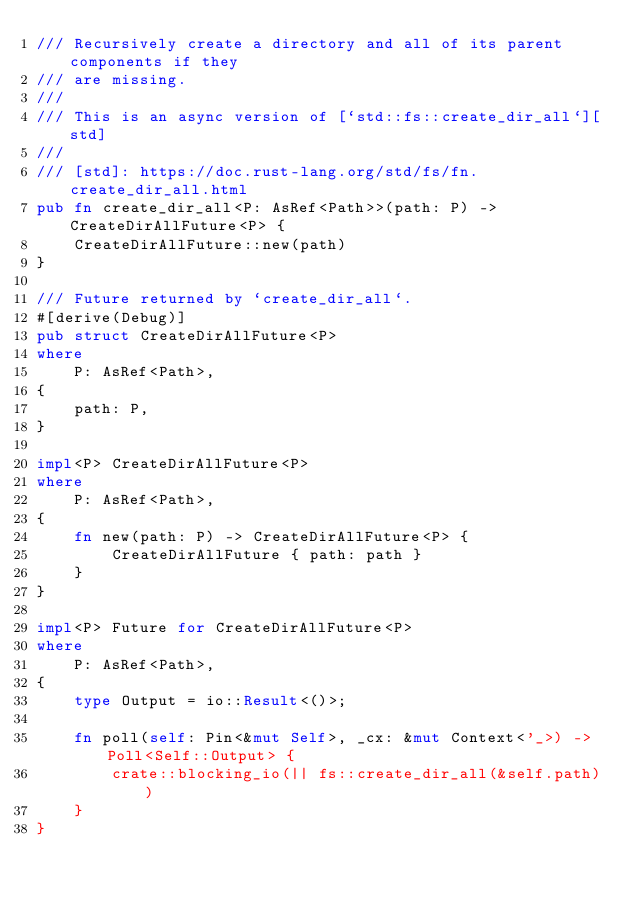<code> <loc_0><loc_0><loc_500><loc_500><_Rust_>/// Recursively create a directory and all of its parent components if they
/// are missing.
///
/// This is an async version of [`std::fs::create_dir_all`][std]
///
/// [std]: https://doc.rust-lang.org/std/fs/fn.create_dir_all.html
pub fn create_dir_all<P: AsRef<Path>>(path: P) -> CreateDirAllFuture<P> {
    CreateDirAllFuture::new(path)
}

/// Future returned by `create_dir_all`.
#[derive(Debug)]
pub struct CreateDirAllFuture<P>
where
    P: AsRef<Path>,
{
    path: P,
}

impl<P> CreateDirAllFuture<P>
where
    P: AsRef<Path>,
{
    fn new(path: P) -> CreateDirAllFuture<P> {
        CreateDirAllFuture { path: path }
    }
}

impl<P> Future for CreateDirAllFuture<P>
where
    P: AsRef<Path>,
{
    type Output = io::Result<()>;

    fn poll(self: Pin<&mut Self>, _cx: &mut Context<'_>) -> Poll<Self::Output> {
        crate::blocking_io(|| fs::create_dir_all(&self.path))
    }
}
</code> 